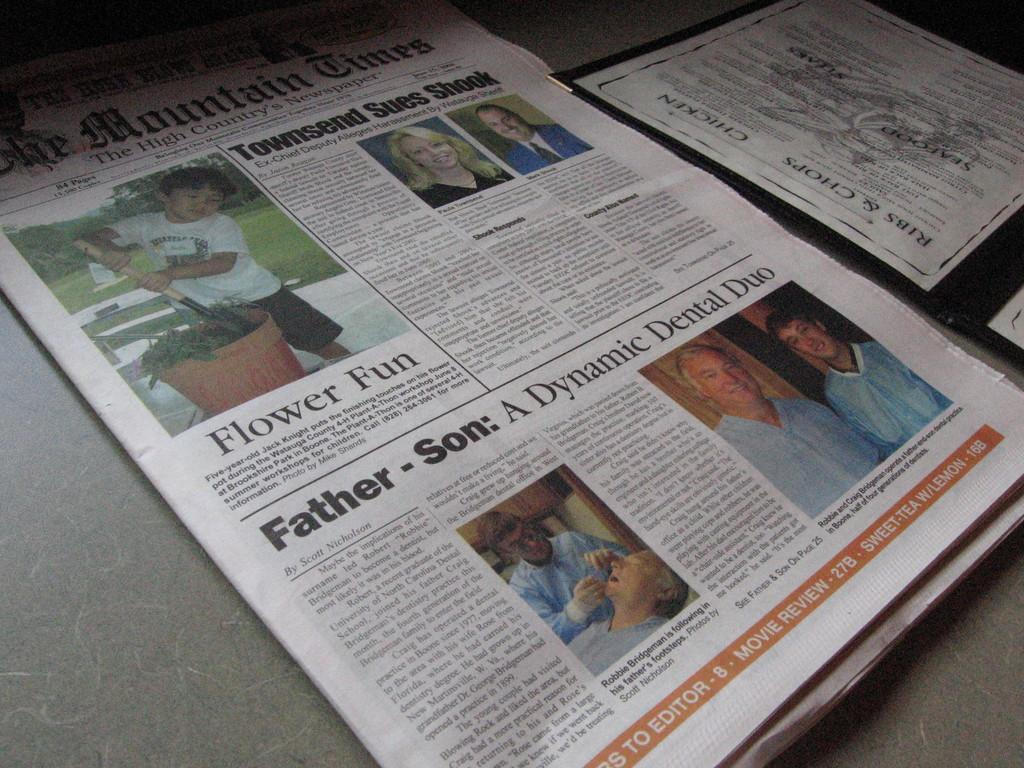<image>
Describe the image concisely. Newspaper article with a section called Flower Fun. 